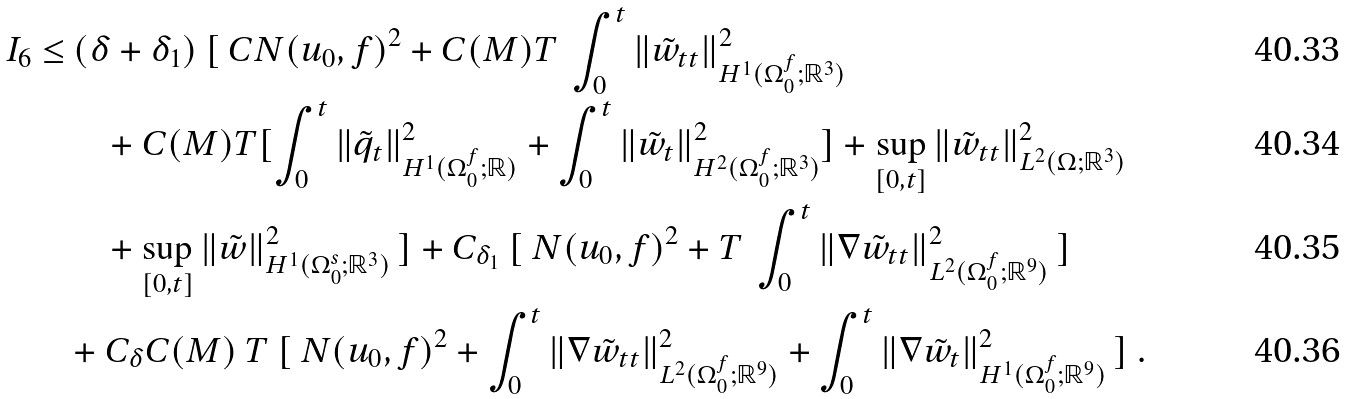Convert formula to latex. <formula><loc_0><loc_0><loc_500><loc_500>I _ { 6 } \leq & \ ( \delta + \delta _ { 1 } ) \ [ \ C N ( u _ { 0 } , f ) ^ { 2 } + C ( M ) T \ \int _ { 0 } ^ { t } \| \tilde { w } _ { t t } \| ^ { 2 } _ { H ^ { 1 } ( \Omega _ { 0 } ^ { f } ; { \mathbb { R } } ^ { 3 } ) } \\ & \quad + C ( M ) T [ \int _ { 0 } ^ { t } \| \tilde { q } _ { t } \| ^ { 2 } _ { H ^ { 1 } ( \Omega _ { 0 } ^ { f } ; { \mathbb { R } } ) } + \int _ { 0 } ^ { t } \| \tilde { w } _ { t } \| ^ { 2 } _ { H ^ { 2 } ( \Omega _ { 0 } ^ { f } ; { \mathbb { R } } ^ { 3 } ) } ] + \sup _ { [ 0 , t ] } \| \tilde { w } _ { t t } \| ^ { 2 } _ { L ^ { 2 } ( \Omega ; { \mathbb { R } } ^ { 3 } ) } \\ & \quad + \sup _ { [ 0 , t ] } \| \tilde { w } \| ^ { 2 } _ { H ^ { 1 } ( \Omega _ { 0 } ^ { s } ; { \mathbb { R } } ^ { 3 } ) } \ ] + C _ { \delta _ { 1 } } \ [ \ N ( u _ { 0 } , f ) ^ { 2 } + T \ \int _ { 0 } ^ { t } \| \nabla \tilde { w } _ { t t } \| ^ { 2 } _ { L ^ { 2 } ( \Omega _ { 0 } ^ { f } ; { \mathbb { R } } ^ { 9 } ) } \ ] \\ & + C _ { \delta } C ( M ) \ T \ [ \ N ( u _ { 0 } , f ) ^ { 2 } + \int _ { 0 } ^ { t } \| \nabla \tilde { w } _ { t t } \| ^ { 2 } _ { L ^ { 2 } ( \Omega _ { 0 } ^ { f } ; { \mathbb { R } } ^ { 9 } ) } + \int _ { 0 } ^ { t } \| \nabla \tilde { w } _ { t } \| ^ { 2 } _ { H ^ { 1 } ( \Omega _ { 0 } ^ { f } ; { \mathbb { R } } ^ { 9 } ) } \ ] \ .</formula> 